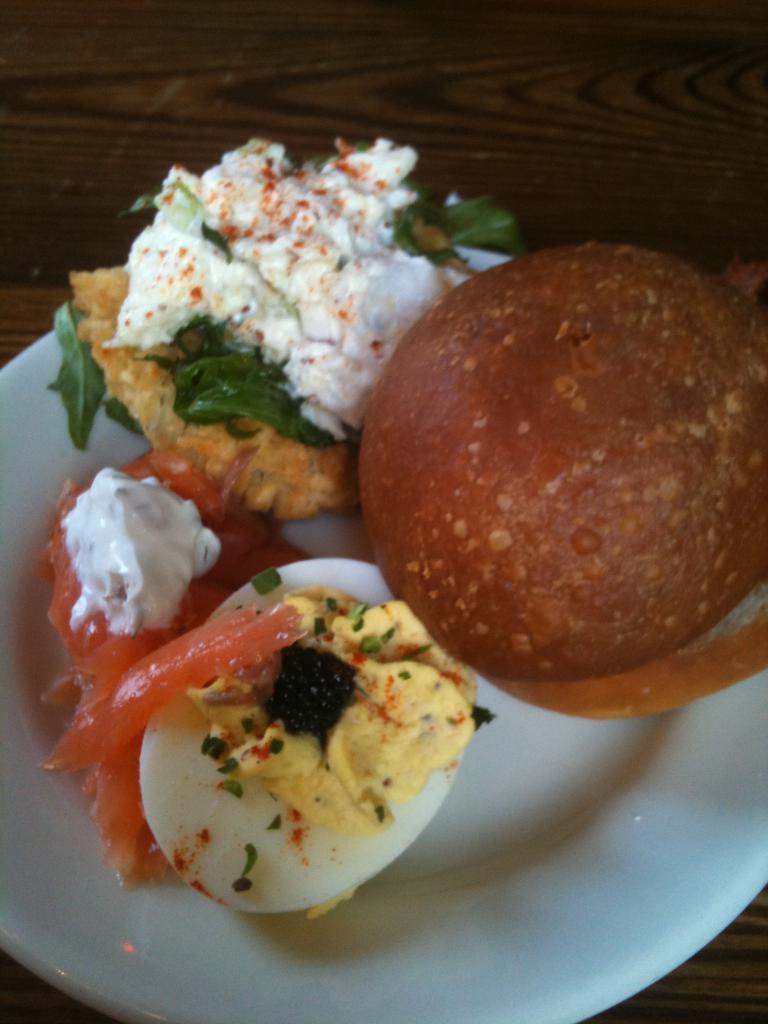Describe this image in one or two sentences. In the picture we can see a plate on the wooden plank, on the table we can see some food items like egg slice and some cream beside it and a sweet. 